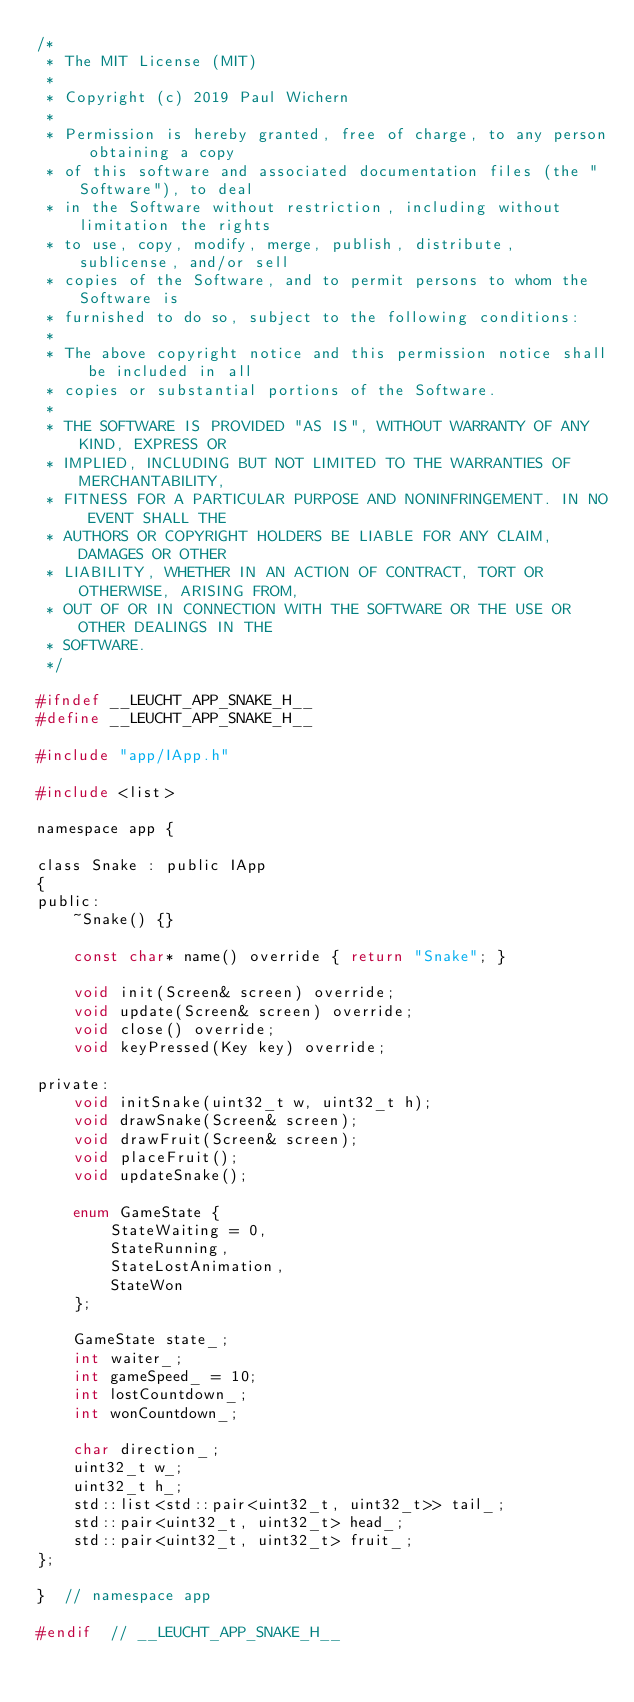<code> <loc_0><loc_0><loc_500><loc_500><_C_>/*
 * The MIT License (MIT)
 *
 * Copyright (c) 2019 Paul Wichern
 *
 * Permission is hereby granted, free of charge, to any person obtaining a copy
 * of this software and associated documentation files (the "Software"), to deal
 * in the Software without restriction, including without limitation the rights
 * to use, copy, modify, merge, publish, distribute, sublicense, and/or sell
 * copies of the Software, and to permit persons to whom the Software is
 * furnished to do so, subject to the following conditions:
 *
 * The above copyright notice and this permission notice shall be included in all
 * copies or substantial portions of the Software.
 *
 * THE SOFTWARE IS PROVIDED "AS IS", WITHOUT WARRANTY OF ANY KIND, EXPRESS OR
 * IMPLIED, INCLUDING BUT NOT LIMITED TO THE WARRANTIES OF MERCHANTABILITY,
 * FITNESS FOR A PARTICULAR PURPOSE AND NONINFRINGEMENT. IN NO EVENT SHALL THE
 * AUTHORS OR COPYRIGHT HOLDERS BE LIABLE FOR ANY CLAIM, DAMAGES OR OTHER
 * LIABILITY, WHETHER IN AN ACTION OF CONTRACT, TORT OR OTHERWISE, ARISING FROM,
 * OUT OF OR IN CONNECTION WITH THE SOFTWARE OR THE USE OR OTHER DEALINGS IN THE
 * SOFTWARE.
 */

#ifndef __LEUCHT_APP_SNAKE_H__
#define __LEUCHT_APP_SNAKE_H__

#include "app/IApp.h"

#include <list>

namespace app {

class Snake : public IApp
{
public:
    ~Snake() {}

    const char* name() override { return "Snake"; }

    void init(Screen& screen) override;
    void update(Screen& screen) override;
    void close() override;
    void keyPressed(Key key) override;

private:
    void initSnake(uint32_t w, uint32_t h);
    void drawSnake(Screen& screen);
    void drawFruit(Screen& screen);
    void placeFruit();
    void updateSnake();

    enum GameState {
        StateWaiting = 0,
        StateRunning,
        StateLostAnimation,
        StateWon
    };

    GameState state_;
    int waiter_;
    int gameSpeed_ = 10;
    int lostCountdown_;
    int wonCountdown_;

    char direction_;
    uint32_t w_;
    uint32_t h_;
    std::list<std::pair<uint32_t, uint32_t>> tail_;
    std::pair<uint32_t, uint32_t> head_;
    std::pair<uint32_t, uint32_t> fruit_;
};

}  // namespace app

#endif  // __LEUCHT_APP_SNAKE_H__
</code> 